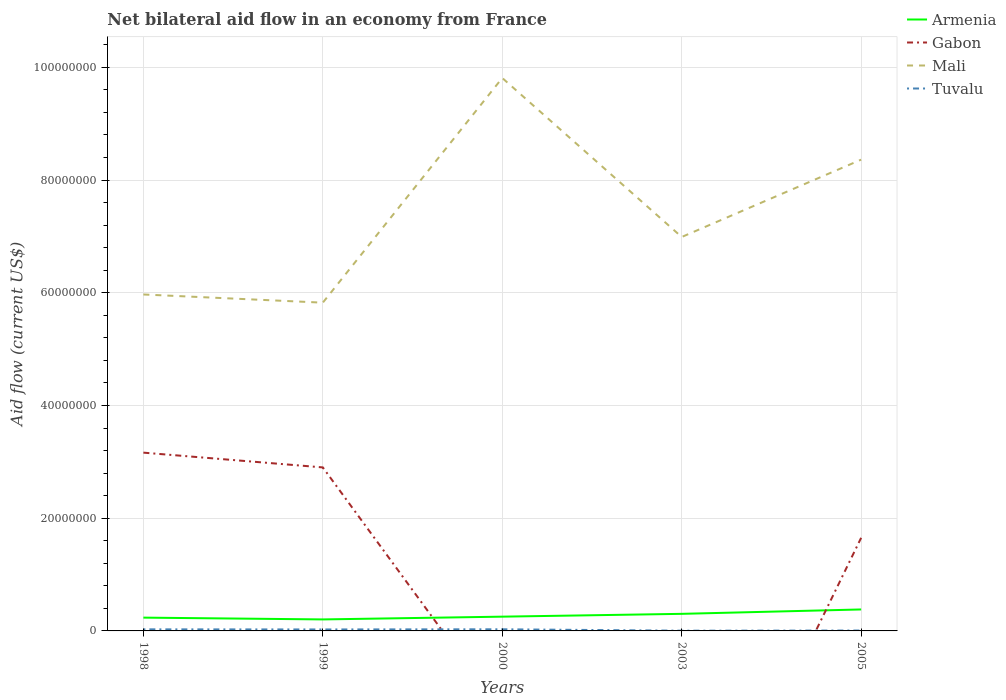Does the line corresponding to Gabon intersect with the line corresponding to Armenia?
Keep it short and to the point. Yes. Across all years, what is the maximum net bilateral aid flow in Tuvalu?
Provide a succinct answer. 4.00e+04. What is the total net bilateral aid flow in Mali in the graph?
Ensure brevity in your answer.  -3.84e+07. What is the difference between the highest and the second highest net bilateral aid flow in Mali?
Provide a short and direct response. 3.99e+07. What is the difference between the highest and the lowest net bilateral aid flow in Armenia?
Your response must be concise. 2. Is the net bilateral aid flow in Gabon strictly greater than the net bilateral aid flow in Tuvalu over the years?
Ensure brevity in your answer.  No. What is the difference between two consecutive major ticks on the Y-axis?
Provide a succinct answer. 2.00e+07. Does the graph contain any zero values?
Offer a terse response. Yes. How are the legend labels stacked?
Your answer should be compact. Vertical. What is the title of the graph?
Provide a short and direct response. Net bilateral aid flow in an economy from France. What is the label or title of the X-axis?
Offer a very short reply. Years. What is the Aid flow (current US$) in Armenia in 1998?
Your answer should be compact. 2.36e+06. What is the Aid flow (current US$) of Gabon in 1998?
Keep it short and to the point. 3.16e+07. What is the Aid flow (current US$) in Mali in 1998?
Make the answer very short. 5.97e+07. What is the Aid flow (current US$) of Tuvalu in 1998?
Your answer should be very brief. 2.80e+05. What is the Aid flow (current US$) in Armenia in 1999?
Your answer should be compact. 2.04e+06. What is the Aid flow (current US$) of Gabon in 1999?
Your answer should be very brief. 2.90e+07. What is the Aid flow (current US$) of Mali in 1999?
Your response must be concise. 5.82e+07. What is the Aid flow (current US$) of Armenia in 2000?
Offer a very short reply. 2.53e+06. What is the Aid flow (current US$) in Gabon in 2000?
Ensure brevity in your answer.  0. What is the Aid flow (current US$) of Mali in 2000?
Make the answer very short. 9.81e+07. What is the Aid flow (current US$) of Armenia in 2003?
Make the answer very short. 3.03e+06. What is the Aid flow (current US$) in Gabon in 2003?
Provide a succinct answer. 0. What is the Aid flow (current US$) in Mali in 2003?
Offer a terse response. 6.99e+07. What is the Aid flow (current US$) of Tuvalu in 2003?
Provide a short and direct response. 4.00e+04. What is the Aid flow (current US$) in Armenia in 2005?
Make the answer very short. 3.81e+06. What is the Aid flow (current US$) of Gabon in 2005?
Provide a succinct answer. 1.65e+07. What is the Aid flow (current US$) of Mali in 2005?
Your response must be concise. 8.36e+07. What is the Aid flow (current US$) in Tuvalu in 2005?
Give a very brief answer. 7.00e+04. Across all years, what is the maximum Aid flow (current US$) in Armenia?
Provide a succinct answer. 3.81e+06. Across all years, what is the maximum Aid flow (current US$) of Gabon?
Provide a succinct answer. 3.16e+07. Across all years, what is the maximum Aid flow (current US$) in Mali?
Offer a very short reply. 9.81e+07. Across all years, what is the minimum Aid flow (current US$) of Armenia?
Your answer should be very brief. 2.04e+06. Across all years, what is the minimum Aid flow (current US$) in Mali?
Your answer should be compact. 5.82e+07. Across all years, what is the minimum Aid flow (current US$) of Tuvalu?
Keep it short and to the point. 4.00e+04. What is the total Aid flow (current US$) of Armenia in the graph?
Provide a succinct answer. 1.38e+07. What is the total Aid flow (current US$) of Gabon in the graph?
Make the answer very short. 7.72e+07. What is the total Aid flow (current US$) in Mali in the graph?
Your answer should be very brief. 3.70e+08. What is the total Aid flow (current US$) of Tuvalu in the graph?
Provide a succinct answer. 9.40e+05. What is the difference between the Aid flow (current US$) of Gabon in 1998 and that in 1999?
Your response must be concise. 2.62e+06. What is the difference between the Aid flow (current US$) of Mali in 1998 and that in 1999?
Give a very brief answer. 1.45e+06. What is the difference between the Aid flow (current US$) of Mali in 1998 and that in 2000?
Give a very brief answer. -3.84e+07. What is the difference between the Aid flow (current US$) of Tuvalu in 1998 and that in 2000?
Give a very brief answer. -10000. What is the difference between the Aid flow (current US$) in Armenia in 1998 and that in 2003?
Keep it short and to the point. -6.70e+05. What is the difference between the Aid flow (current US$) in Mali in 1998 and that in 2003?
Provide a succinct answer. -1.02e+07. What is the difference between the Aid flow (current US$) in Armenia in 1998 and that in 2005?
Give a very brief answer. -1.45e+06. What is the difference between the Aid flow (current US$) of Gabon in 1998 and that in 2005?
Give a very brief answer. 1.51e+07. What is the difference between the Aid flow (current US$) of Mali in 1998 and that in 2005?
Your answer should be very brief. -2.39e+07. What is the difference between the Aid flow (current US$) of Tuvalu in 1998 and that in 2005?
Offer a terse response. 2.10e+05. What is the difference between the Aid flow (current US$) in Armenia in 1999 and that in 2000?
Your response must be concise. -4.90e+05. What is the difference between the Aid flow (current US$) in Mali in 1999 and that in 2000?
Your response must be concise. -3.99e+07. What is the difference between the Aid flow (current US$) in Tuvalu in 1999 and that in 2000?
Ensure brevity in your answer.  -3.00e+04. What is the difference between the Aid flow (current US$) of Armenia in 1999 and that in 2003?
Your response must be concise. -9.90e+05. What is the difference between the Aid flow (current US$) in Mali in 1999 and that in 2003?
Provide a succinct answer. -1.16e+07. What is the difference between the Aid flow (current US$) in Tuvalu in 1999 and that in 2003?
Provide a succinct answer. 2.20e+05. What is the difference between the Aid flow (current US$) of Armenia in 1999 and that in 2005?
Ensure brevity in your answer.  -1.77e+06. What is the difference between the Aid flow (current US$) in Gabon in 1999 and that in 2005?
Your response must be concise. 1.25e+07. What is the difference between the Aid flow (current US$) of Mali in 1999 and that in 2005?
Your answer should be very brief. -2.54e+07. What is the difference between the Aid flow (current US$) of Armenia in 2000 and that in 2003?
Offer a very short reply. -5.00e+05. What is the difference between the Aid flow (current US$) of Mali in 2000 and that in 2003?
Make the answer very short. 2.82e+07. What is the difference between the Aid flow (current US$) in Tuvalu in 2000 and that in 2003?
Your answer should be compact. 2.50e+05. What is the difference between the Aid flow (current US$) of Armenia in 2000 and that in 2005?
Offer a very short reply. -1.28e+06. What is the difference between the Aid flow (current US$) of Mali in 2000 and that in 2005?
Provide a succinct answer. 1.45e+07. What is the difference between the Aid flow (current US$) in Tuvalu in 2000 and that in 2005?
Give a very brief answer. 2.20e+05. What is the difference between the Aid flow (current US$) of Armenia in 2003 and that in 2005?
Give a very brief answer. -7.80e+05. What is the difference between the Aid flow (current US$) in Mali in 2003 and that in 2005?
Your answer should be compact. -1.37e+07. What is the difference between the Aid flow (current US$) of Tuvalu in 2003 and that in 2005?
Give a very brief answer. -3.00e+04. What is the difference between the Aid flow (current US$) in Armenia in 1998 and the Aid flow (current US$) in Gabon in 1999?
Offer a terse response. -2.66e+07. What is the difference between the Aid flow (current US$) in Armenia in 1998 and the Aid flow (current US$) in Mali in 1999?
Make the answer very short. -5.59e+07. What is the difference between the Aid flow (current US$) in Armenia in 1998 and the Aid flow (current US$) in Tuvalu in 1999?
Provide a short and direct response. 2.10e+06. What is the difference between the Aid flow (current US$) of Gabon in 1998 and the Aid flow (current US$) of Mali in 1999?
Provide a short and direct response. -2.66e+07. What is the difference between the Aid flow (current US$) in Gabon in 1998 and the Aid flow (current US$) in Tuvalu in 1999?
Provide a succinct answer. 3.14e+07. What is the difference between the Aid flow (current US$) of Mali in 1998 and the Aid flow (current US$) of Tuvalu in 1999?
Offer a terse response. 5.94e+07. What is the difference between the Aid flow (current US$) in Armenia in 1998 and the Aid flow (current US$) in Mali in 2000?
Keep it short and to the point. -9.57e+07. What is the difference between the Aid flow (current US$) in Armenia in 1998 and the Aid flow (current US$) in Tuvalu in 2000?
Give a very brief answer. 2.07e+06. What is the difference between the Aid flow (current US$) in Gabon in 1998 and the Aid flow (current US$) in Mali in 2000?
Offer a very short reply. -6.65e+07. What is the difference between the Aid flow (current US$) of Gabon in 1998 and the Aid flow (current US$) of Tuvalu in 2000?
Keep it short and to the point. 3.13e+07. What is the difference between the Aid flow (current US$) of Mali in 1998 and the Aid flow (current US$) of Tuvalu in 2000?
Your answer should be compact. 5.94e+07. What is the difference between the Aid flow (current US$) in Armenia in 1998 and the Aid flow (current US$) in Mali in 2003?
Make the answer very short. -6.75e+07. What is the difference between the Aid flow (current US$) of Armenia in 1998 and the Aid flow (current US$) of Tuvalu in 2003?
Provide a short and direct response. 2.32e+06. What is the difference between the Aid flow (current US$) in Gabon in 1998 and the Aid flow (current US$) in Mali in 2003?
Your answer should be compact. -3.83e+07. What is the difference between the Aid flow (current US$) of Gabon in 1998 and the Aid flow (current US$) of Tuvalu in 2003?
Provide a succinct answer. 3.16e+07. What is the difference between the Aid flow (current US$) of Mali in 1998 and the Aid flow (current US$) of Tuvalu in 2003?
Make the answer very short. 5.96e+07. What is the difference between the Aid flow (current US$) in Armenia in 1998 and the Aid flow (current US$) in Gabon in 2005?
Provide a short and direct response. -1.42e+07. What is the difference between the Aid flow (current US$) in Armenia in 1998 and the Aid flow (current US$) in Mali in 2005?
Ensure brevity in your answer.  -8.12e+07. What is the difference between the Aid flow (current US$) in Armenia in 1998 and the Aid flow (current US$) in Tuvalu in 2005?
Your answer should be very brief. 2.29e+06. What is the difference between the Aid flow (current US$) of Gabon in 1998 and the Aid flow (current US$) of Mali in 2005?
Offer a terse response. -5.20e+07. What is the difference between the Aid flow (current US$) of Gabon in 1998 and the Aid flow (current US$) of Tuvalu in 2005?
Offer a terse response. 3.16e+07. What is the difference between the Aid flow (current US$) of Mali in 1998 and the Aid flow (current US$) of Tuvalu in 2005?
Offer a very short reply. 5.96e+07. What is the difference between the Aid flow (current US$) of Armenia in 1999 and the Aid flow (current US$) of Mali in 2000?
Ensure brevity in your answer.  -9.61e+07. What is the difference between the Aid flow (current US$) in Armenia in 1999 and the Aid flow (current US$) in Tuvalu in 2000?
Ensure brevity in your answer.  1.75e+06. What is the difference between the Aid flow (current US$) of Gabon in 1999 and the Aid flow (current US$) of Mali in 2000?
Make the answer very short. -6.91e+07. What is the difference between the Aid flow (current US$) of Gabon in 1999 and the Aid flow (current US$) of Tuvalu in 2000?
Your response must be concise. 2.87e+07. What is the difference between the Aid flow (current US$) in Mali in 1999 and the Aid flow (current US$) in Tuvalu in 2000?
Ensure brevity in your answer.  5.80e+07. What is the difference between the Aid flow (current US$) of Armenia in 1999 and the Aid flow (current US$) of Mali in 2003?
Your answer should be compact. -6.78e+07. What is the difference between the Aid flow (current US$) in Armenia in 1999 and the Aid flow (current US$) in Tuvalu in 2003?
Keep it short and to the point. 2.00e+06. What is the difference between the Aid flow (current US$) of Gabon in 1999 and the Aid flow (current US$) of Mali in 2003?
Your answer should be compact. -4.09e+07. What is the difference between the Aid flow (current US$) in Gabon in 1999 and the Aid flow (current US$) in Tuvalu in 2003?
Offer a terse response. 2.90e+07. What is the difference between the Aid flow (current US$) in Mali in 1999 and the Aid flow (current US$) in Tuvalu in 2003?
Offer a terse response. 5.82e+07. What is the difference between the Aid flow (current US$) of Armenia in 1999 and the Aid flow (current US$) of Gabon in 2005?
Offer a terse response. -1.45e+07. What is the difference between the Aid flow (current US$) of Armenia in 1999 and the Aid flow (current US$) of Mali in 2005?
Your answer should be very brief. -8.16e+07. What is the difference between the Aid flow (current US$) in Armenia in 1999 and the Aid flow (current US$) in Tuvalu in 2005?
Provide a succinct answer. 1.97e+06. What is the difference between the Aid flow (current US$) in Gabon in 1999 and the Aid flow (current US$) in Mali in 2005?
Make the answer very short. -5.46e+07. What is the difference between the Aid flow (current US$) in Gabon in 1999 and the Aid flow (current US$) in Tuvalu in 2005?
Offer a very short reply. 2.89e+07. What is the difference between the Aid flow (current US$) of Mali in 1999 and the Aid flow (current US$) of Tuvalu in 2005?
Ensure brevity in your answer.  5.82e+07. What is the difference between the Aid flow (current US$) in Armenia in 2000 and the Aid flow (current US$) in Mali in 2003?
Offer a very short reply. -6.74e+07. What is the difference between the Aid flow (current US$) in Armenia in 2000 and the Aid flow (current US$) in Tuvalu in 2003?
Make the answer very short. 2.49e+06. What is the difference between the Aid flow (current US$) in Mali in 2000 and the Aid flow (current US$) in Tuvalu in 2003?
Offer a very short reply. 9.81e+07. What is the difference between the Aid flow (current US$) in Armenia in 2000 and the Aid flow (current US$) in Gabon in 2005?
Offer a terse response. -1.40e+07. What is the difference between the Aid flow (current US$) of Armenia in 2000 and the Aid flow (current US$) of Mali in 2005?
Ensure brevity in your answer.  -8.11e+07. What is the difference between the Aid flow (current US$) of Armenia in 2000 and the Aid flow (current US$) of Tuvalu in 2005?
Your answer should be very brief. 2.46e+06. What is the difference between the Aid flow (current US$) of Mali in 2000 and the Aid flow (current US$) of Tuvalu in 2005?
Offer a very short reply. 9.80e+07. What is the difference between the Aid flow (current US$) of Armenia in 2003 and the Aid flow (current US$) of Gabon in 2005?
Your answer should be very brief. -1.35e+07. What is the difference between the Aid flow (current US$) of Armenia in 2003 and the Aid flow (current US$) of Mali in 2005?
Give a very brief answer. -8.06e+07. What is the difference between the Aid flow (current US$) of Armenia in 2003 and the Aid flow (current US$) of Tuvalu in 2005?
Your answer should be compact. 2.96e+06. What is the difference between the Aid flow (current US$) in Mali in 2003 and the Aid flow (current US$) in Tuvalu in 2005?
Your answer should be very brief. 6.98e+07. What is the average Aid flow (current US$) in Armenia per year?
Your answer should be compact. 2.75e+06. What is the average Aid flow (current US$) in Gabon per year?
Keep it short and to the point. 1.54e+07. What is the average Aid flow (current US$) in Mali per year?
Provide a succinct answer. 7.39e+07. What is the average Aid flow (current US$) of Tuvalu per year?
Your response must be concise. 1.88e+05. In the year 1998, what is the difference between the Aid flow (current US$) in Armenia and Aid flow (current US$) in Gabon?
Make the answer very short. -2.93e+07. In the year 1998, what is the difference between the Aid flow (current US$) in Armenia and Aid flow (current US$) in Mali?
Your answer should be compact. -5.73e+07. In the year 1998, what is the difference between the Aid flow (current US$) of Armenia and Aid flow (current US$) of Tuvalu?
Give a very brief answer. 2.08e+06. In the year 1998, what is the difference between the Aid flow (current US$) in Gabon and Aid flow (current US$) in Mali?
Provide a short and direct response. -2.81e+07. In the year 1998, what is the difference between the Aid flow (current US$) in Gabon and Aid flow (current US$) in Tuvalu?
Your answer should be compact. 3.14e+07. In the year 1998, what is the difference between the Aid flow (current US$) of Mali and Aid flow (current US$) of Tuvalu?
Give a very brief answer. 5.94e+07. In the year 1999, what is the difference between the Aid flow (current US$) in Armenia and Aid flow (current US$) in Gabon?
Offer a terse response. -2.70e+07. In the year 1999, what is the difference between the Aid flow (current US$) of Armenia and Aid flow (current US$) of Mali?
Your answer should be compact. -5.62e+07. In the year 1999, what is the difference between the Aid flow (current US$) of Armenia and Aid flow (current US$) of Tuvalu?
Your response must be concise. 1.78e+06. In the year 1999, what is the difference between the Aid flow (current US$) of Gabon and Aid flow (current US$) of Mali?
Offer a terse response. -2.92e+07. In the year 1999, what is the difference between the Aid flow (current US$) in Gabon and Aid flow (current US$) in Tuvalu?
Offer a terse response. 2.88e+07. In the year 1999, what is the difference between the Aid flow (current US$) of Mali and Aid flow (current US$) of Tuvalu?
Make the answer very short. 5.80e+07. In the year 2000, what is the difference between the Aid flow (current US$) of Armenia and Aid flow (current US$) of Mali?
Ensure brevity in your answer.  -9.56e+07. In the year 2000, what is the difference between the Aid flow (current US$) in Armenia and Aid flow (current US$) in Tuvalu?
Your answer should be very brief. 2.24e+06. In the year 2000, what is the difference between the Aid flow (current US$) of Mali and Aid flow (current US$) of Tuvalu?
Your response must be concise. 9.78e+07. In the year 2003, what is the difference between the Aid flow (current US$) of Armenia and Aid flow (current US$) of Mali?
Give a very brief answer. -6.69e+07. In the year 2003, what is the difference between the Aid flow (current US$) in Armenia and Aid flow (current US$) in Tuvalu?
Offer a very short reply. 2.99e+06. In the year 2003, what is the difference between the Aid flow (current US$) of Mali and Aid flow (current US$) of Tuvalu?
Provide a short and direct response. 6.98e+07. In the year 2005, what is the difference between the Aid flow (current US$) in Armenia and Aid flow (current US$) in Gabon?
Give a very brief answer. -1.27e+07. In the year 2005, what is the difference between the Aid flow (current US$) in Armenia and Aid flow (current US$) in Mali?
Make the answer very short. -7.98e+07. In the year 2005, what is the difference between the Aid flow (current US$) of Armenia and Aid flow (current US$) of Tuvalu?
Offer a very short reply. 3.74e+06. In the year 2005, what is the difference between the Aid flow (current US$) of Gabon and Aid flow (current US$) of Mali?
Your answer should be very brief. -6.71e+07. In the year 2005, what is the difference between the Aid flow (current US$) of Gabon and Aid flow (current US$) of Tuvalu?
Make the answer very short. 1.64e+07. In the year 2005, what is the difference between the Aid flow (current US$) of Mali and Aid flow (current US$) of Tuvalu?
Ensure brevity in your answer.  8.35e+07. What is the ratio of the Aid flow (current US$) in Armenia in 1998 to that in 1999?
Provide a short and direct response. 1.16. What is the ratio of the Aid flow (current US$) in Gabon in 1998 to that in 1999?
Offer a very short reply. 1.09. What is the ratio of the Aid flow (current US$) in Mali in 1998 to that in 1999?
Provide a succinct answer. 1.02. What is the ratio of the Aid flow (current US$) in Armenia in 1998 to that in 2000?
Make the answer very short. 0.93. What is the ratio of the Aid flow (current US$) in Mali in 1998 to that in 2000?
Ensure brevity in your answer.  0.61. What is the ratio of the Aid flow (current US$) in Tuvalu in 1998 to that in 2000?
Offer a terse response. 0.97. What is the ratio of the Aid flow (current US$) of Armenia in 1998 to that in 2003?
Provide a succinct answer. 0.78. What is the ratio of the Aid flow (current US$) in Mali in 1998 to that in 2003?
Provide a short and direct response. 0.85. What is the ratio of the Aid flow (current US$) in Armenia in 1998 to that in 2005?
Provide a short and direct response. 0.62. What is the ratio of the Aid flow (current US$) in Gabon in 1998 to that in 2005?
Your answer should be compact. 1.91. What is the ratio of the Aid flow (current US$) of Mali in 1998 to that in 2005?
Ensure brevity in your answer.  0.71. What is the ratio of the Aid flow (current US$) in Tuvalu in 1998 to that in 2005?
Your response must be concise. 4. What is the ratio of the Aid flow (current US$) in Armenia in 1999 to that in 2000?
Give a very brief answer. 0.81. What is the ratio of the Aid flow (current US$) of Mali in 1999 to that in 2000?
Make the answer very short. 0.59. What is the ratio of the Aid flow (current US$) of Tuvalu in 1999 to that in 2000?
Keep it short and to the point. 0.9. What is the ratio of the Aid flow (current US$) of Armenia in 1999 to that in 2003?
Your answer should be very brief. 0.67. What is the ratio of the Aid flow (current US$) in Mali in 1999 to that in 2003?
Provide a succinct answer. 0.83. What is the ratio of the Aid flow (current US$) of Tuvalu in 1999 to that in 2003?
Provide a short and direct response. 6.5. What is the ratio of the Aid flow (current US$) of Armenia in 1999 to that in 2005?
Your response must be concise. 0.54. What is the ratio of the Aid flow (current US$) in Gabon in 1999 to that in 2005?
Provide a succinct answer. 1.76. What is the ratio of the Aid flow (current US$) of Mali in 1999 to that in 2005?
Offer a terse response. 0.7. What is the ratio of the Aid flow (current US$) in Tuvalu in 1999 to that in 2005?
Your answer should be compact. 3.71. What is the ratio of the Aid flow (current US$) in Armenia in 2000 to that in 2003?
Ensure brevity in your answer.  0.83. What is the ratio of the Aid flow (current US$) in Mali in 2000 to that in 2003?
Your answer should be compact. 1.4. What is the ratio of the Aid flow (current US$) in Tuvalu in 2000 to that in 2003?
Give a very brief answer. 7.25. What is the ratio of the Aid flow (current US$) in Armenia in 2000 to that in 2005?
Provide a succinct answer. 0.66. What is the ratio of the Aid flow (current US$) of Mali in 2000 to that in 2005?
Make the answer very short. 1.17. What is the ratio of the Aid flow (current US$) of Tuvalu in 2000 to that in 2005?
Your answer should be compact. 4.14. What is the ratio of the Aid flow (current US$) of Armenia in 2003 to that in 2005?
Provide a succinct answer. 0.8. What is the ratio of the Aid flow (current US$) in Mali in 2003 to that in 2005?
Ensure brevity in your answer.  0.84. What is the difference between the highest and the second highest Aid flow (current US$) in Armenia?
Provide a short and direct response. 7.80e+05. What is the difference between the highest and the second highest Aid flow (current US$) of Gabon?
Provide a succinct answer. 2.62e+06. What is the difference between the highest and the second highest Aid flow (current US$) of Mali?
Your answer should be very brief. 1.45e+07. What is the difference between the highest and the lowest Aid flow (current US$) of Armenia?
Offer a very short reply. 1.77e+06. What is the difference between the highest and the lowest Aid flow (current US$) in Gabon?
Make the answer very short. 3.16e+07. What is the difference between the highest and the lowest Aid flow (current US$) of Mali?
Your answer should be very brief. 3.99e+07. 